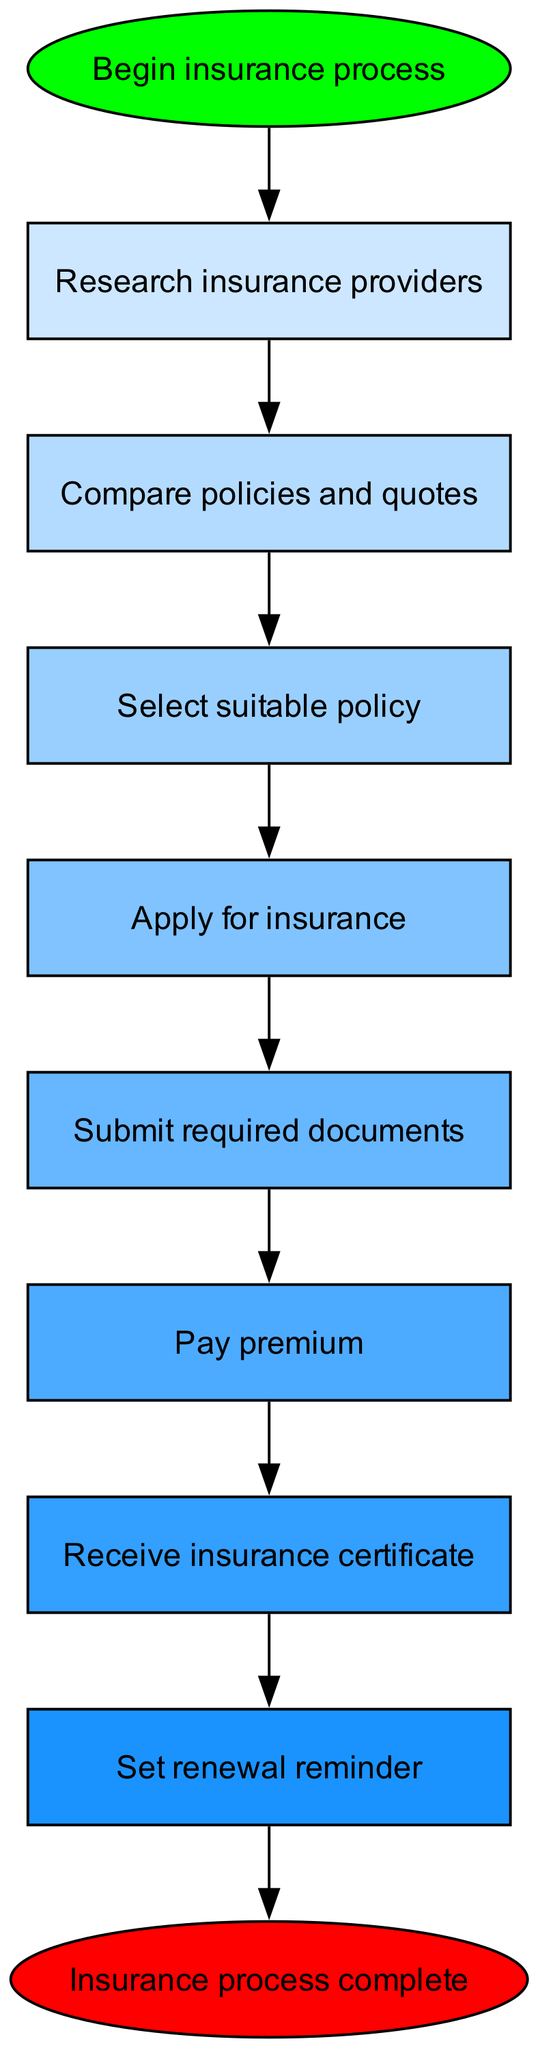What is the first step in the insurance process? The diagram indicates that the first step is "Begin insurance process," which is the starting point of the flow.
Answer: Begin insurance process How many nodes are in the diagram? By counting the specified elements in the data, there are 10 nodes mentioned in total.
Answer: 10 What comes after "Select suitable policy"? The diagram shows that the next step following "Select suitable policy" is "Apply for insurance." This follows the directional flow of the chart.
Answer: Apply for insurance What is the last step in the insurance process? According to the diagram, the last step in the insurance process is "Insurance process complete," which signifies the end of the procedure.
Answer: Insurance process complete What is the relationship between "Submit required documents" and "Pay premium"? The diagram indicates a direct flow from "Submit required documents" to "Pay premium," signifying that you need to submit documents before making the payment.
Answer: Submit required documents → Pay premium Which step involves receiving an official document? The step that involves receiving an official document is "Receive insurance certificate," which comes after paying the premium.
Answer: Receive insurance certificate What should you do after receiving the insurance certificate? After receiving the insurance certificate, the next action should be to "Set renewal reminder," indicating a proactive measure for future policy renewal.
Answer: Set renewal reminder How many connections exist between the nodes? By examining the connections listed, there are 9 connections that show the flow between the various steps in the insurance process.
Answer: 9 What color is the node for "Select suitable policy"? The node "Select suitable policy" is filled with a blue color according to the color palette provided in the diagram.
Answer: Blue What action is taken immediately after "Pay premium"? The immediate action that follows "Pay premium" is "Receive insurance certificate," signaling that payment leads to receiving proof of coverage.
Answer: Receive insurance certificate 